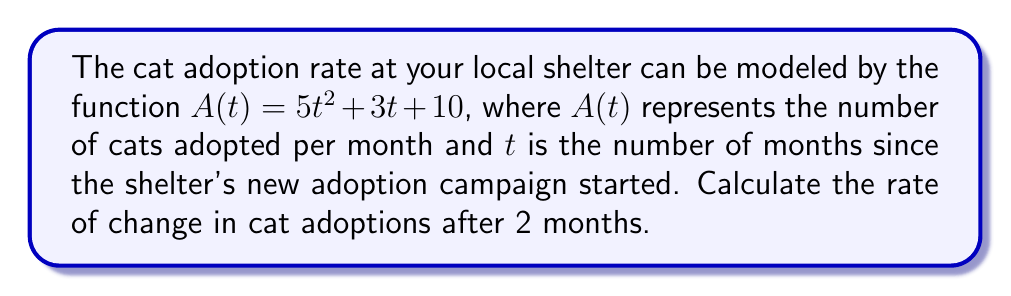Can you answer this question? To find the rate of change in cat adoptions after 2 months, we need to calculate the derivative of the given function $A(t)$ and then evaluate it at $t = 2$.

Step 1: Find the derivative of $A(t)$.
$$\frac{d}{dt}A(t) = \frac{d}{dt}(5t^2 + 3t + 10)$$
$$A'(t) = 10t + 3$$

Step 2: Evaluate the derivative at $t = 2$.
$$A'(2) = 10(2) + 3$$
$$A'(2) = 20 + 3 = 23$$

The rate of change in cat adoptions after 2 months is 23 cats per month per month. This means that at the 2-month mark, the number of cat adoptions is increasing at a rate of 23 cats per month.
Answer: $23$ cats/month² 